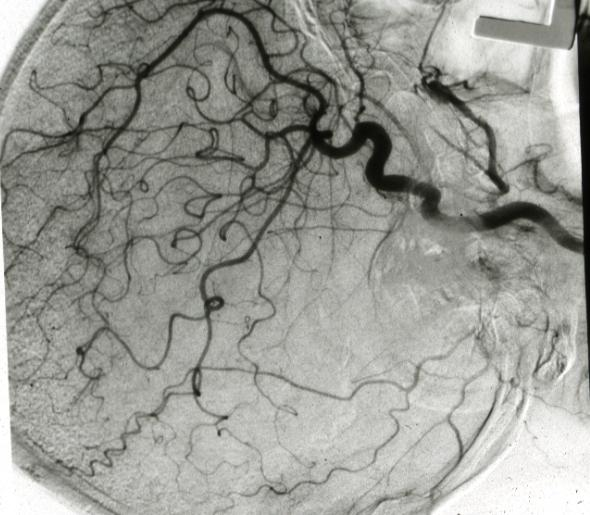what does this image show?
Answer the question using a single word or phrase. X-ray left side angiogram 